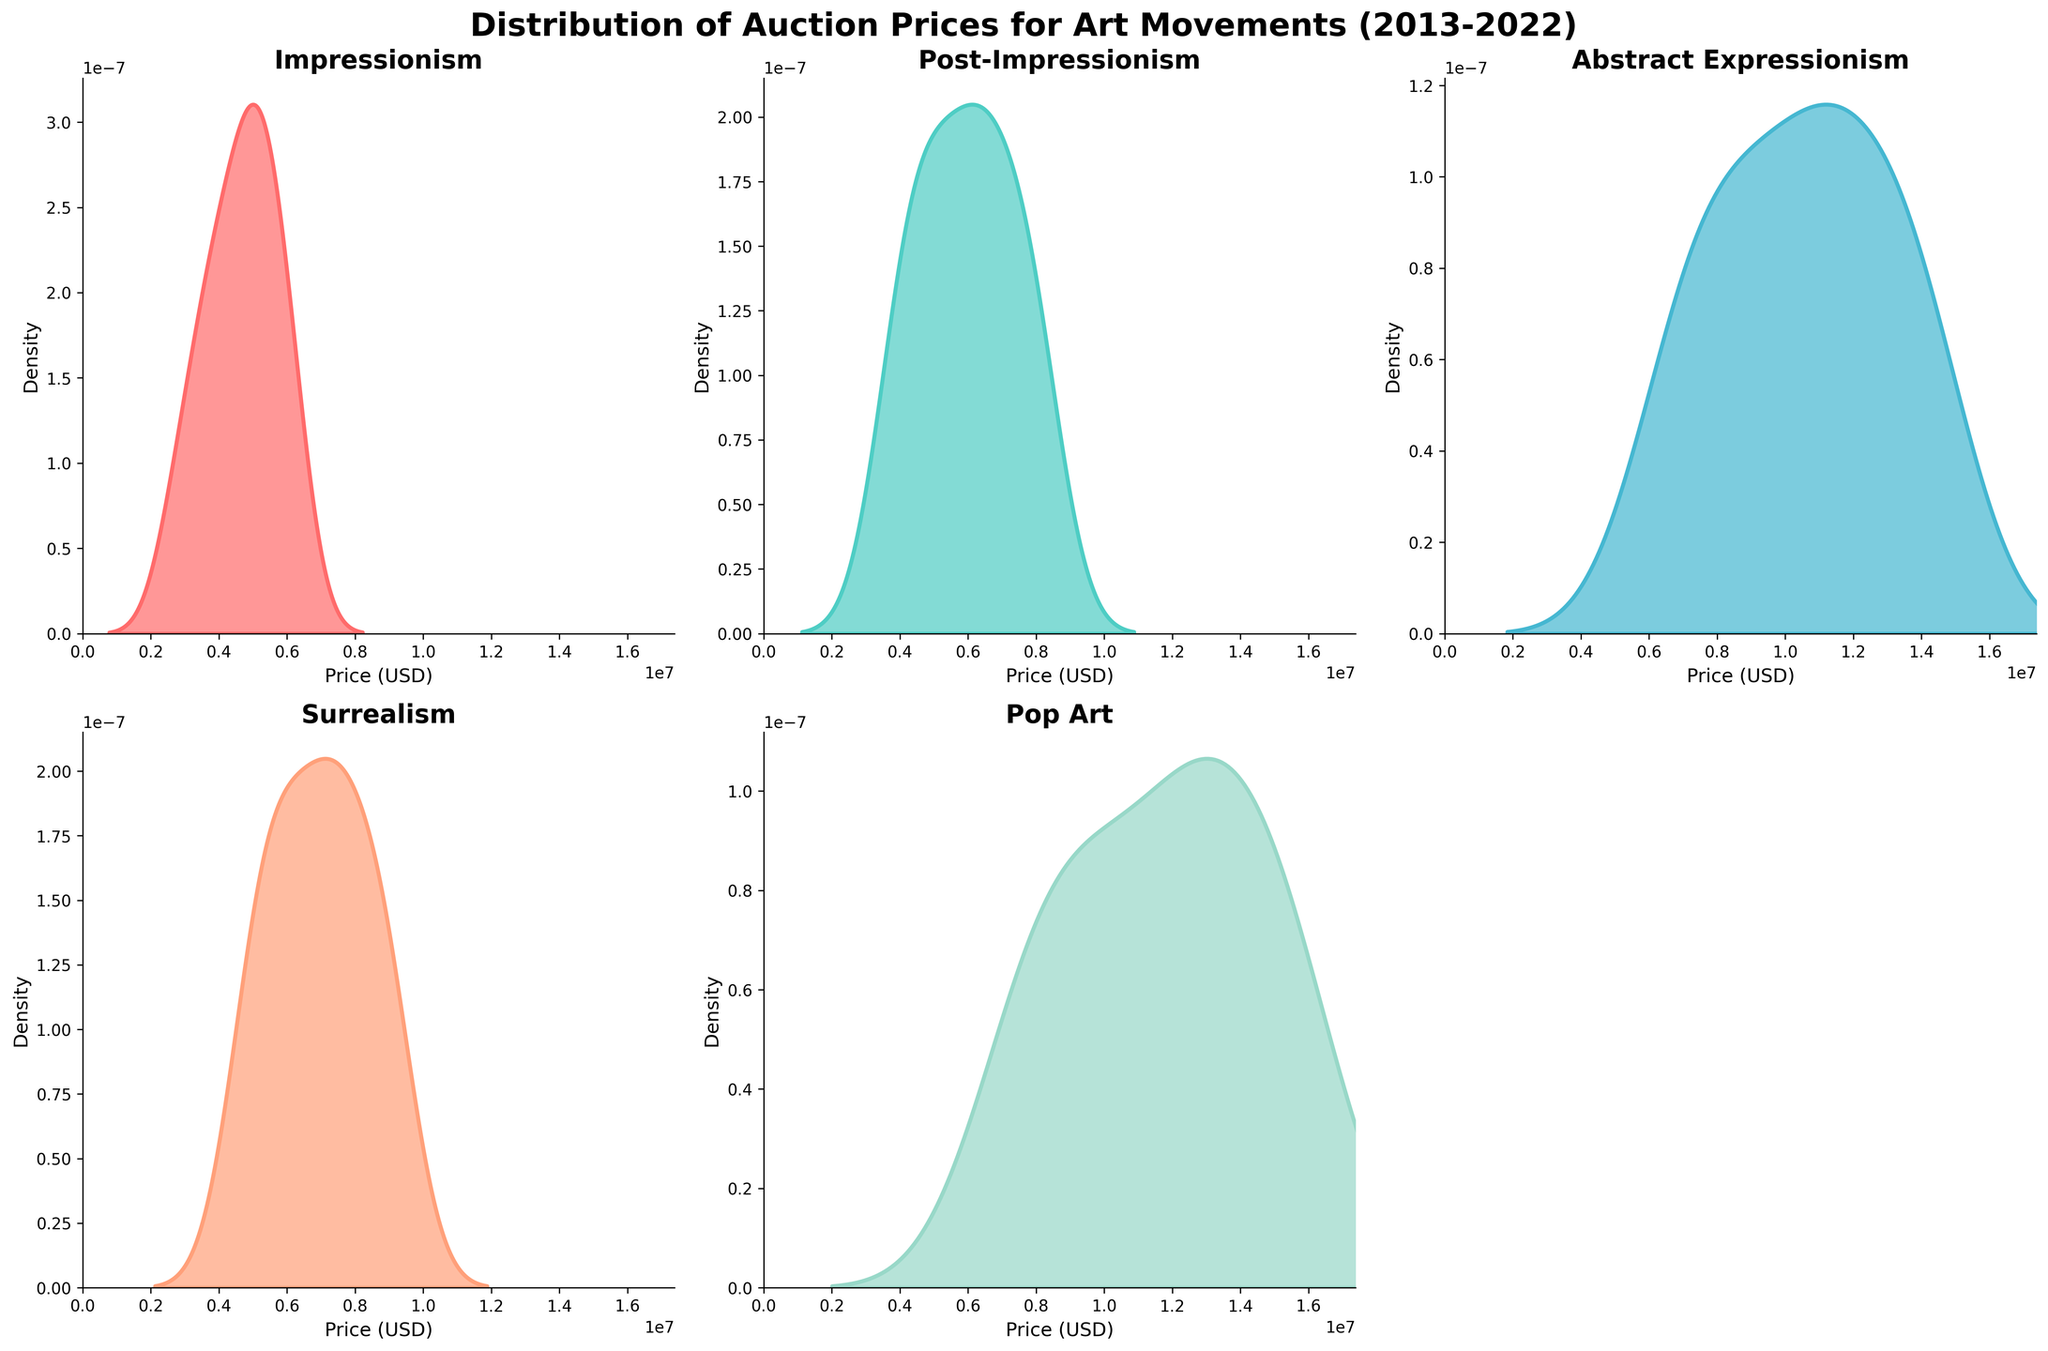What is the title of the figure? The title of the figure is located at the top center and it summarizes the content of the plot.
Answer: Distribution of Auction Prices for Art Movements (2013-2022) Which art movement has the highest peak in the density plot? By examining the height of the density peaks within each subplot, we can determine which one is the highest.
Answer: Abstract Expressionism What are the axes labels for each subplot? Each subplot has an x-axis labeled 'Price (USD)' and a y-axis labeled 'Density'. The axes labels are consistent across all subplots.
Answer: Price (USD) and Density Which subplot does not show any data? By examining all the subplots, we see that one subplot is empty.
Answer: The bottom-right subplot is empty Between which years does the data span for these density plots? The data points span the years from the minimum to the maximum year values on the x-axis across all subplots.
Answer: 2013-2022 Which art movement has the widest price distribution? By looking at the range of x-values covered by the density plot for each art movement, the one with the widest spread has the broadest distribution.
Answer: Pop Art Compare the peak prices of Impressionism and Surrealism. Which one has a higher auction price peak? By comparing the highest points of the density plots for Impressionism and Surrealism, we can see which has a higher peak.
Answer: Impressionism How do the price densities of Pop Art compare to those of Abstract Expressionism? Both Pop Art and Abstract Expressionism have their peaks at high price values. By looking at the density plots, Abstract Expressionism has a slightly higher density peak than Pop Art.
Answer: Abstract Expressionism is denser What can you infer about the density plot for Post-Impressionism in terms of price trends over the years? By observing the shape and spread of the density plot for Post-Impressionism, we can infer if the prices are generally increasing, decreasing, or varied. The density plot indicates more frequent high prices in recent years.
Answer: Increasing trend What is the most common price range for Surrealism? The peak of the density plot for Surrealism represents the most common price range for this art movement, found by identifying the x-axis value at the highest plot point.
Answer: Around $7.5M to $9M 